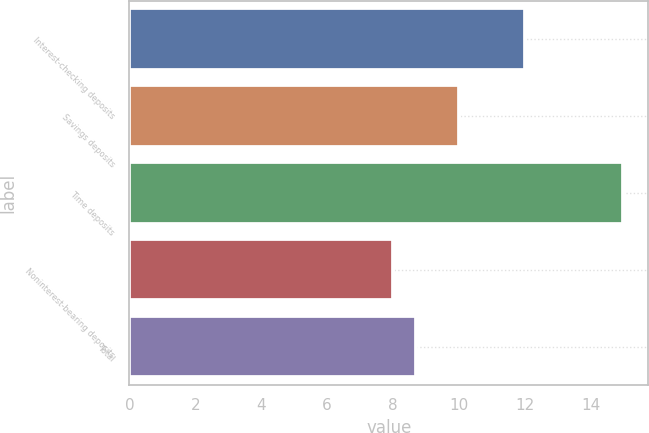Convert chart to OTSL. <chart><loc_0><loc_0><loc_500><loc_500><bar_chart><fcel>Interest-checking deposits<fcel>Savings deposits<fcel>Time deposits<fcel>Noninterest-bearing deposits<fcel>Total<nl><fcel>12<fcel>10<fcel>15<fcel>8<fcel>8.7<nl></chart> 